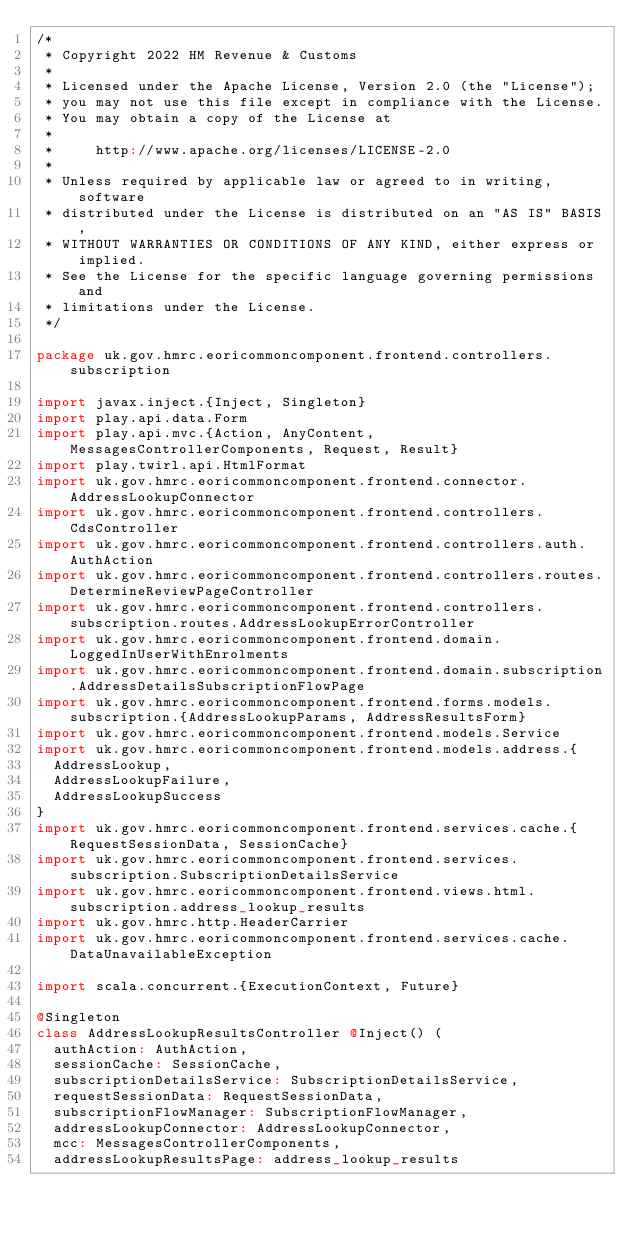Convert code to text. <code><loc_0><loc_0><loc_500><loc_500><_Scala_>/*
 * Copyright 2022 HM Revenue & Customs
 *
 * Licensed under the Apache License, Version 2.0 (the "License");
 * you may not use this file except in compliance with the License.
 * You may obtain a copy of the License at
 *
 *     http://www.apache.org/licenses/LICENSE-2.0
 *
 * Unless required by applicable law or agreed to in writing, software
 * distributed under the License is distributed on an "AS IS" BASIS,
 * WITHOUT WARRANTIES OR CONDITIONS OF ANY KIND, either express or implied.
 * See the License for the specific language governing permissions and
 * limitations under the License.
 */

package uk.gov.hmrc.eoricommoncomponent.frontend.controllers.subscription

import javax.inject.{Inject, Singleton}
import play.api.data.Form
import play.api.mvc.{Action, AnyContent, MessagesControllerComponents, Request, Result}
import play.twirl.api.HtmlFormat
import uk.gov.hmrc.eoricommoncomponent.frontend.connector.AddressLookupConnector
import uk.gov.hmrc.eoricommoncomponent.frontend.controllers.CdsController
import uk.gov.hmrc.eoricommoncomponent.frontend.controllers.auth.AuthAction
import uk.gov.hmrc.eoricommoncomponent.frontend.controllers.routes.DetermineReviewPageController
import uk.gov.hmrc.eoricommoncomponent.frontend.controllers.subscription.routes.AddressLookupErrorController
import uk.gov.hmrc.eoricommoncomponent.frontend.domain.LoggedInUserWithEnrolments
import uk.gov.hmrc.eoricommoncomponent.frontend.domain.subscription.AddressDetailsSubscriptionFlowPage
import uk.gov.hmrc.eoricommoncomponent.frontend.forms.models.subscription.{AddressLookupParams, AddressResultsForm}
import uk.gov.hmrc.eoricommoncomponent.frontend.models.Service
import uk.gov.hmrc.eoricommoncomponent.frontend.models.address.{
  AddressLookup,
  AddressLookupFailure,
  AddressLookupSuccess
}
import uk.gov.hmrc.eoricommoncomponent.frontend.services.cache.{RequestSessionData, SessionCache}
import uk.gov.hmrc.eoricommoncomponent.frontend.services.subscription.SubscriptionDetailsService
import uk.gov.hmrc.eoricommoncomponent.frontend.views.html.subscription.address_lookup_results
import uk.gov.hmrc.http.HeaderCarrier
import uk.gov.hmrc.eoricommoncomponent.frontend.services.cache.DataUnavailableException

import scala.concurrent.{ExecutionContext, Future}

@Singleton
class AddressLookupResultsController @Inject() (
  authAction: AuthAction,
  sessionCache: SessionCache,
  subscriptionDetailsService: SubscriptionDetailsService,
  requestSessionData: RequestSessionData,
  subscriptionFlowManager: SubscriptionFlowManager,
  addressLookupConnector: AddressLookupConnector,
  mcc: MessagesControllerComponents,
  addressLookupResultsPage: address_lookup_results</code> 